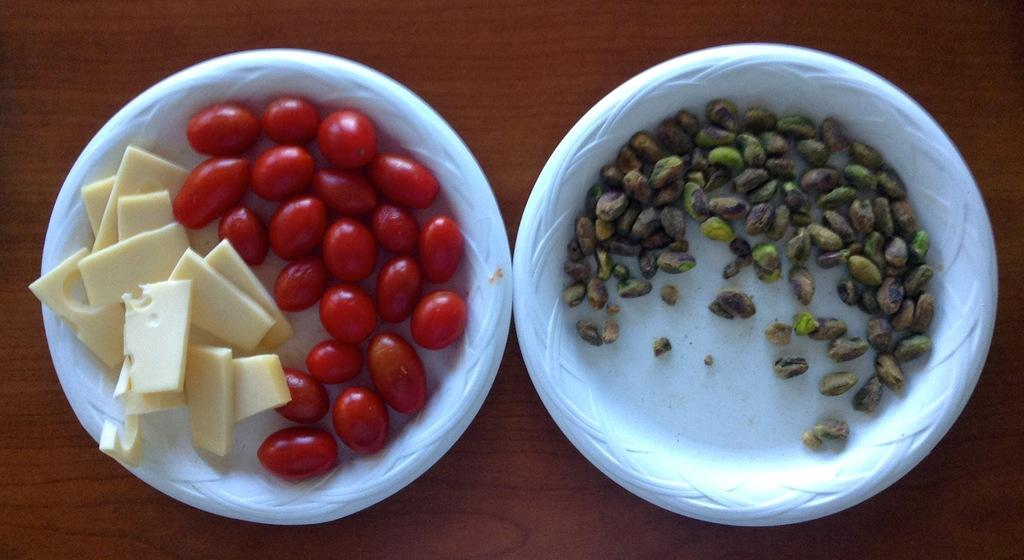How many plates are visible in the image? There are two white color plates in the image. What is on the plates? There are food items on the plates. What crime is being committed in the image? There is no crime being committed in the image; it simply shows two plates with food items on them. 